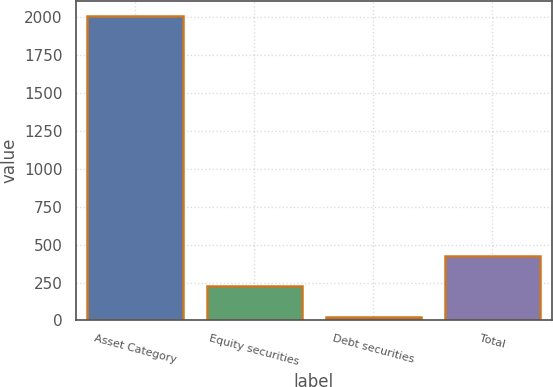Convert chart to OTSL. <chart><loc_0><loc_0><loc_500><loc_500><bar_chart><fcel>Asset Category<fcel>Equity securities<fcel>Debt securities<fcel>Total<nl><fcel>2006<fcel>224<fcel>26<fcel>422<nl></chart> 